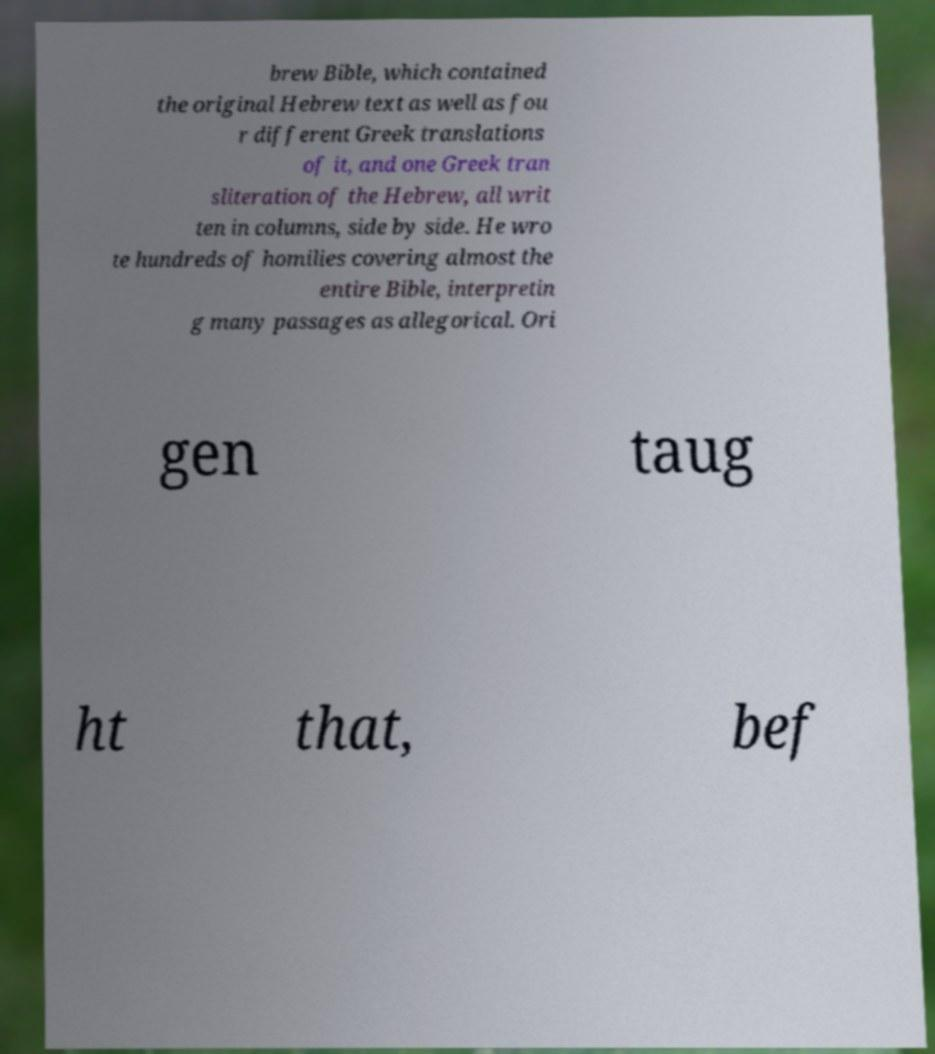For documentation purposes, I need the text within this image transcribed. Could you provide that? brew Bible, which contained the original Hebrew text as well as fou r different Greek translations of it, and one Greek tran sliteration of the Hebrew, all writ ten in columns, side by side. He wro te hundreds of homilies covering almost the entire Bible, interpretin g many passages as allegorical. Ori gen taug ht that, bef 